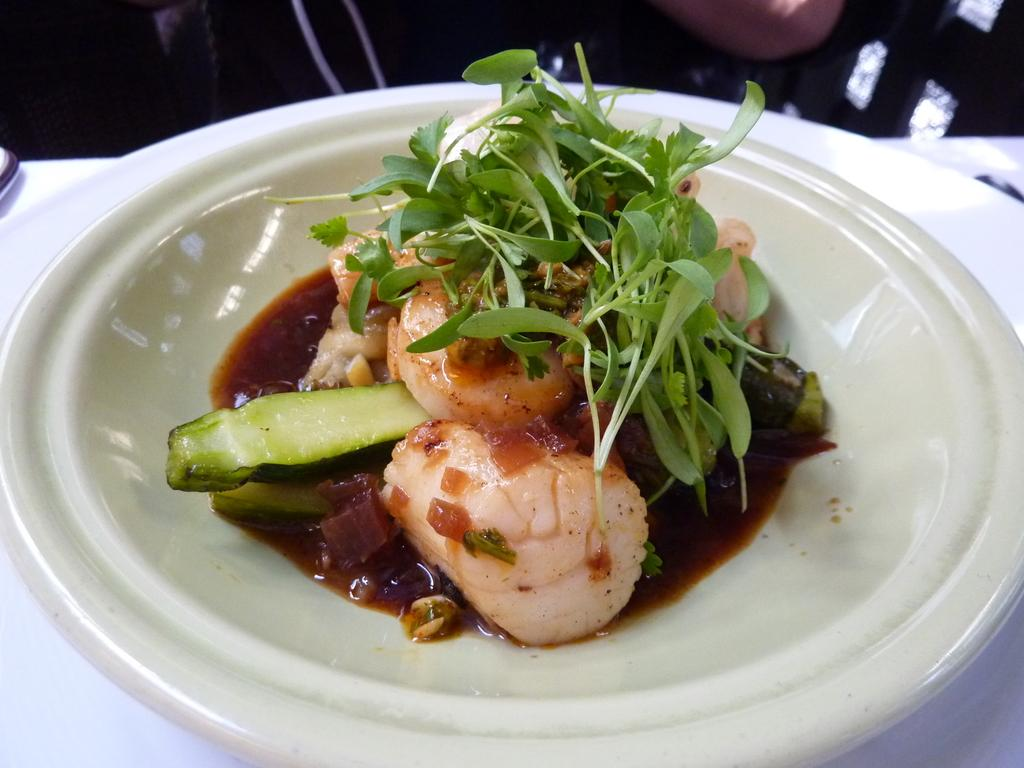What is on the plate that is visible in the image? There is food on a plate in the image. Where is the plate located in the image? The plate is placed on a table in the image. Can you describe the person in the background of the image? There is a person in the background of the image, but no specific details are provided about the person. What type of dog is resting under the table in the image? There is no dog present in the image; it only shows a plate of food on a table with a person in the background. 